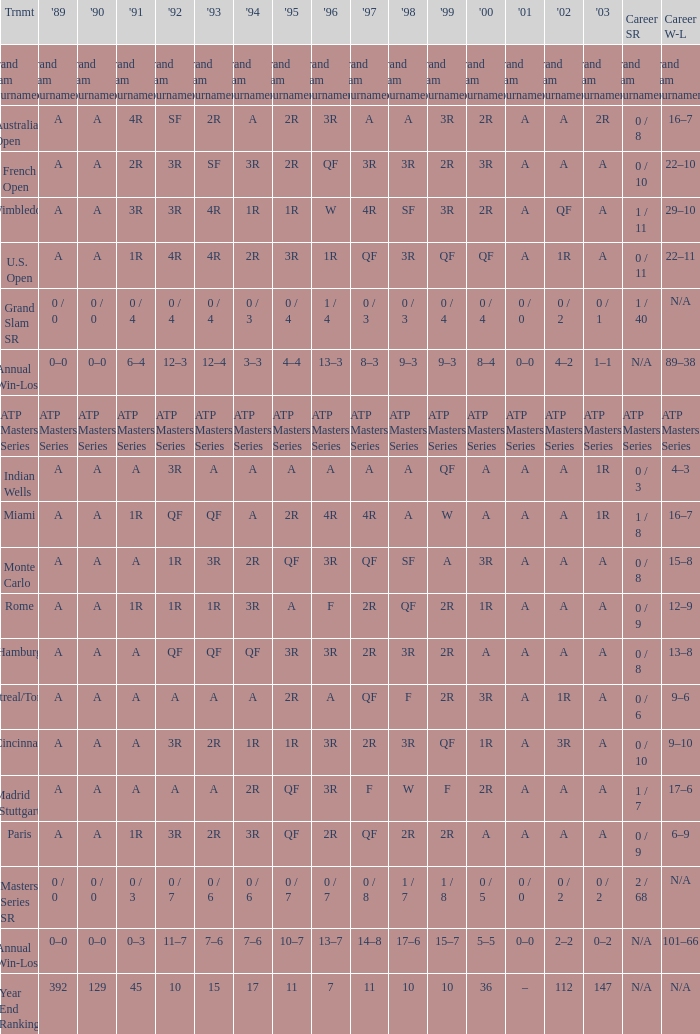What was the career SR with a value of A in 1980 and F in 1997? 1 / 7. 